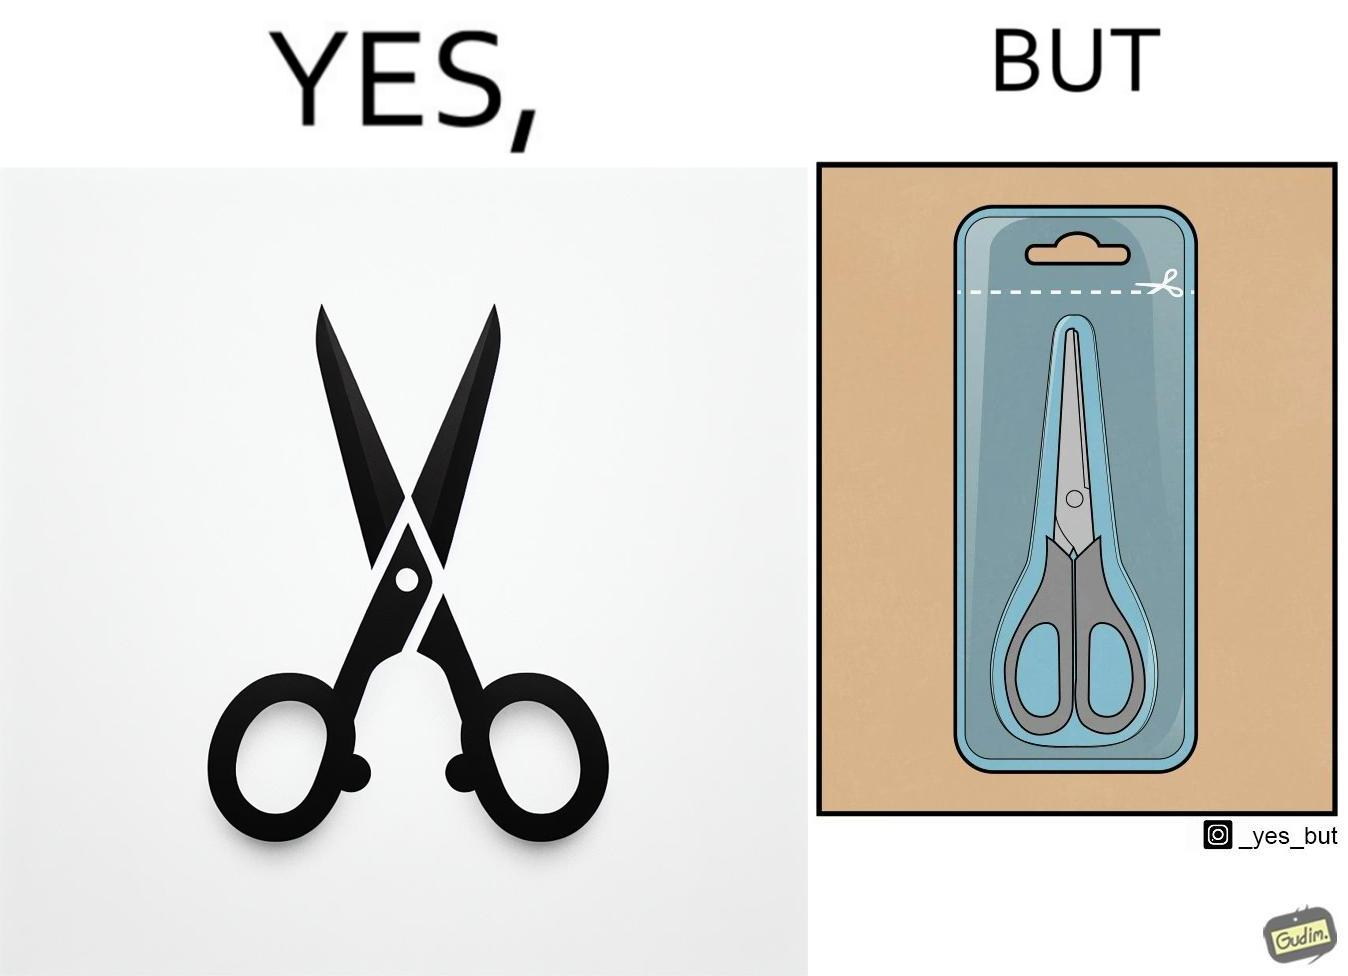What does this image depict? the image is funny, as the marking at the top of the packaging shows that you would need a pair of scissors to in-turn cut open the pair of scissors that is inside the packaging. 